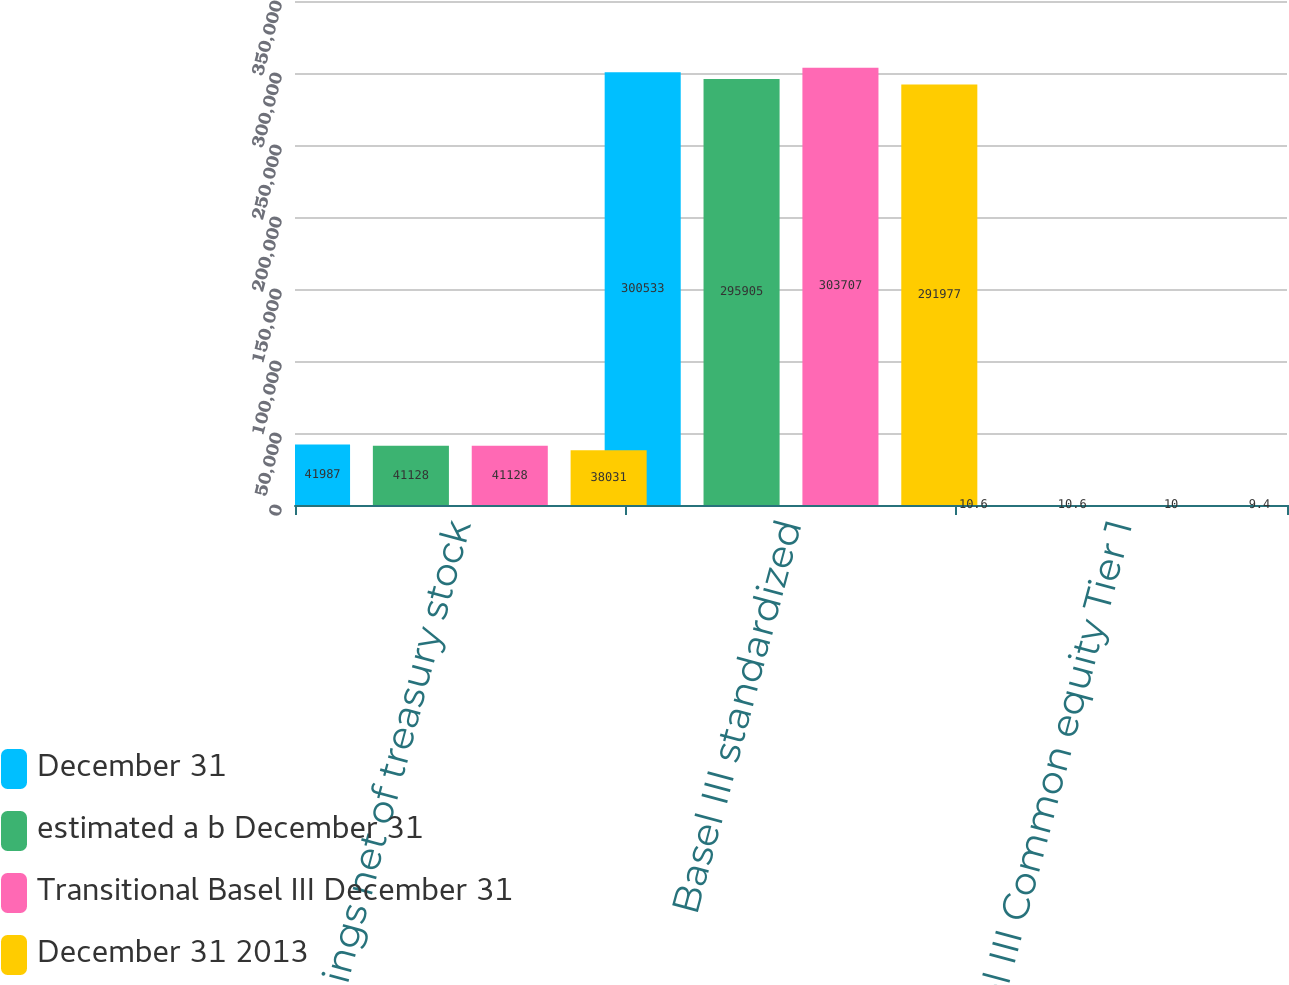Convert chart. <chart><loc_0><loc_0><loc_500><loc_500><stacked_bar_chart><ecel><fcel>earnings net of treasury stock<fcel>Basel III standardized<fcel>Basel III Common equity Tier 1<nl><fcel>December 31<fcel>41987<fcel>300533<fcel>10.6<nl><fcel>estimated a b December 31<fcel>41128<fcel>295905<fcel>10.6<nl><fcel>Transitional Basel III December 31<fcel>41128<fcel>303707<fcel>10<nl><fcel>December 31 2013<fcel>38031<fcel>291977<fcel>9.4<nl></chart> 